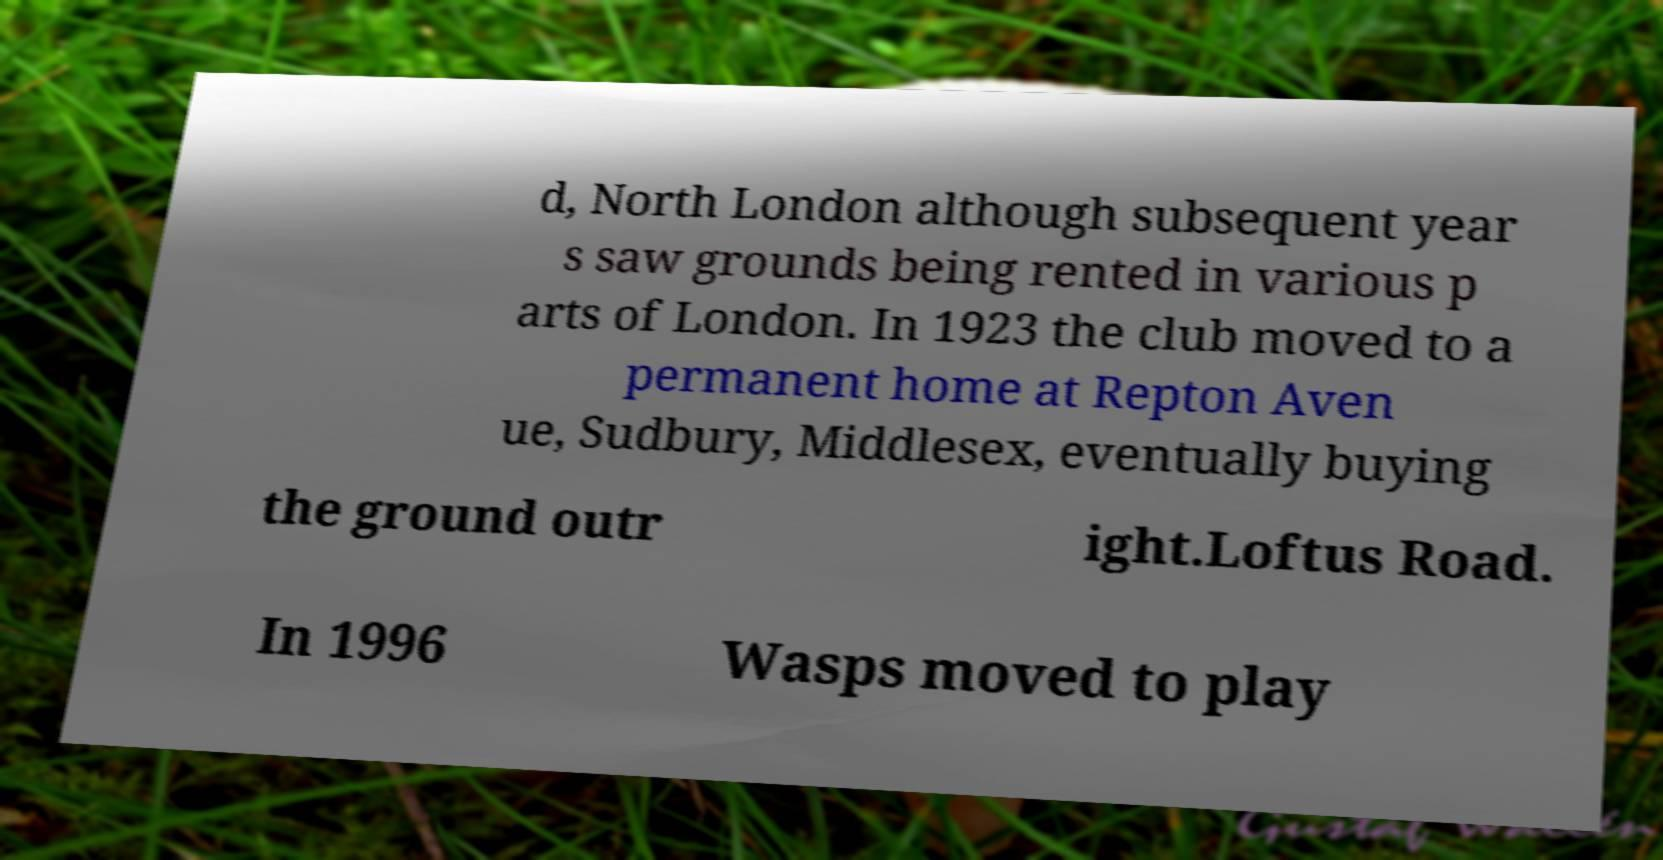Could you assist in decoding the text presented in this image and type it out clearly? d, North London although subsequent year s saw grounds being rented in various p arts of London. In 1923 the club moved to a permanent home at Repton Aven ue, Sudbury, Middlesex, eventually buying the ground outr ight.Loftus Road. In 1996 Wasps moved to play 